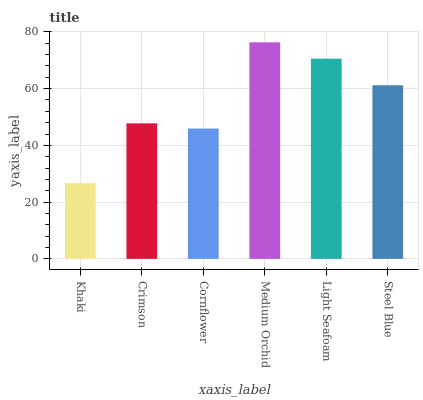Is Khaki the minimum?
Answer yes or no. Yes. Is Medium Orchid the maximum?
Answer yes or no. Yes. Is Crimson the minimum?
Answer yes or no. No. Is Crimson the maximum?
Answer yes or no. No. Is Crimson greater than Khaki?
Answer yes or no. Yes. Is Khaki less than Crimson?
Answer yes or no. Yes. Is Khaki greater than Crimson?
Answer yes or no. No. Is Crimson less than Khaki?
Answer yes or no. No. Is Steel Blue the high median?
Answer yes or no. Yes. Is Crimson the low median?
Answer yes or no. Yes. Is Light Seafoam the high median?
Answer yes or no. No. Is Light Seafoam the low median?
Answer yes or no. No. 